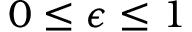<formula> <loc_0><loc_0><loc_500><loc_500>0 \leq \epsilon \leq 1</formula> 